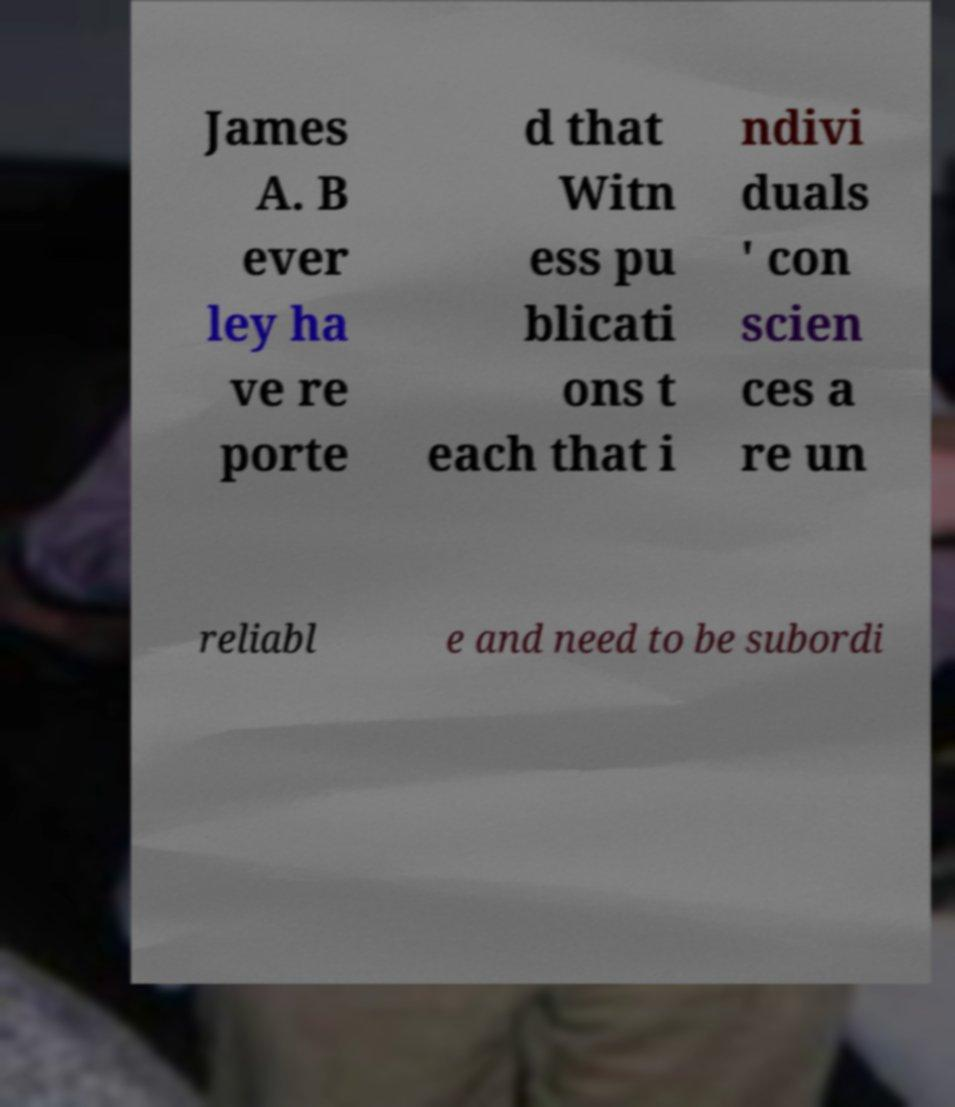I need the written content from this picture converted into text. Can you do that? James A. B ever ley ha ve re porte d that Witn ess pu blicati ons t each that i ndivi duals ' con scien ces a re un reliabl e and need to be subordi 